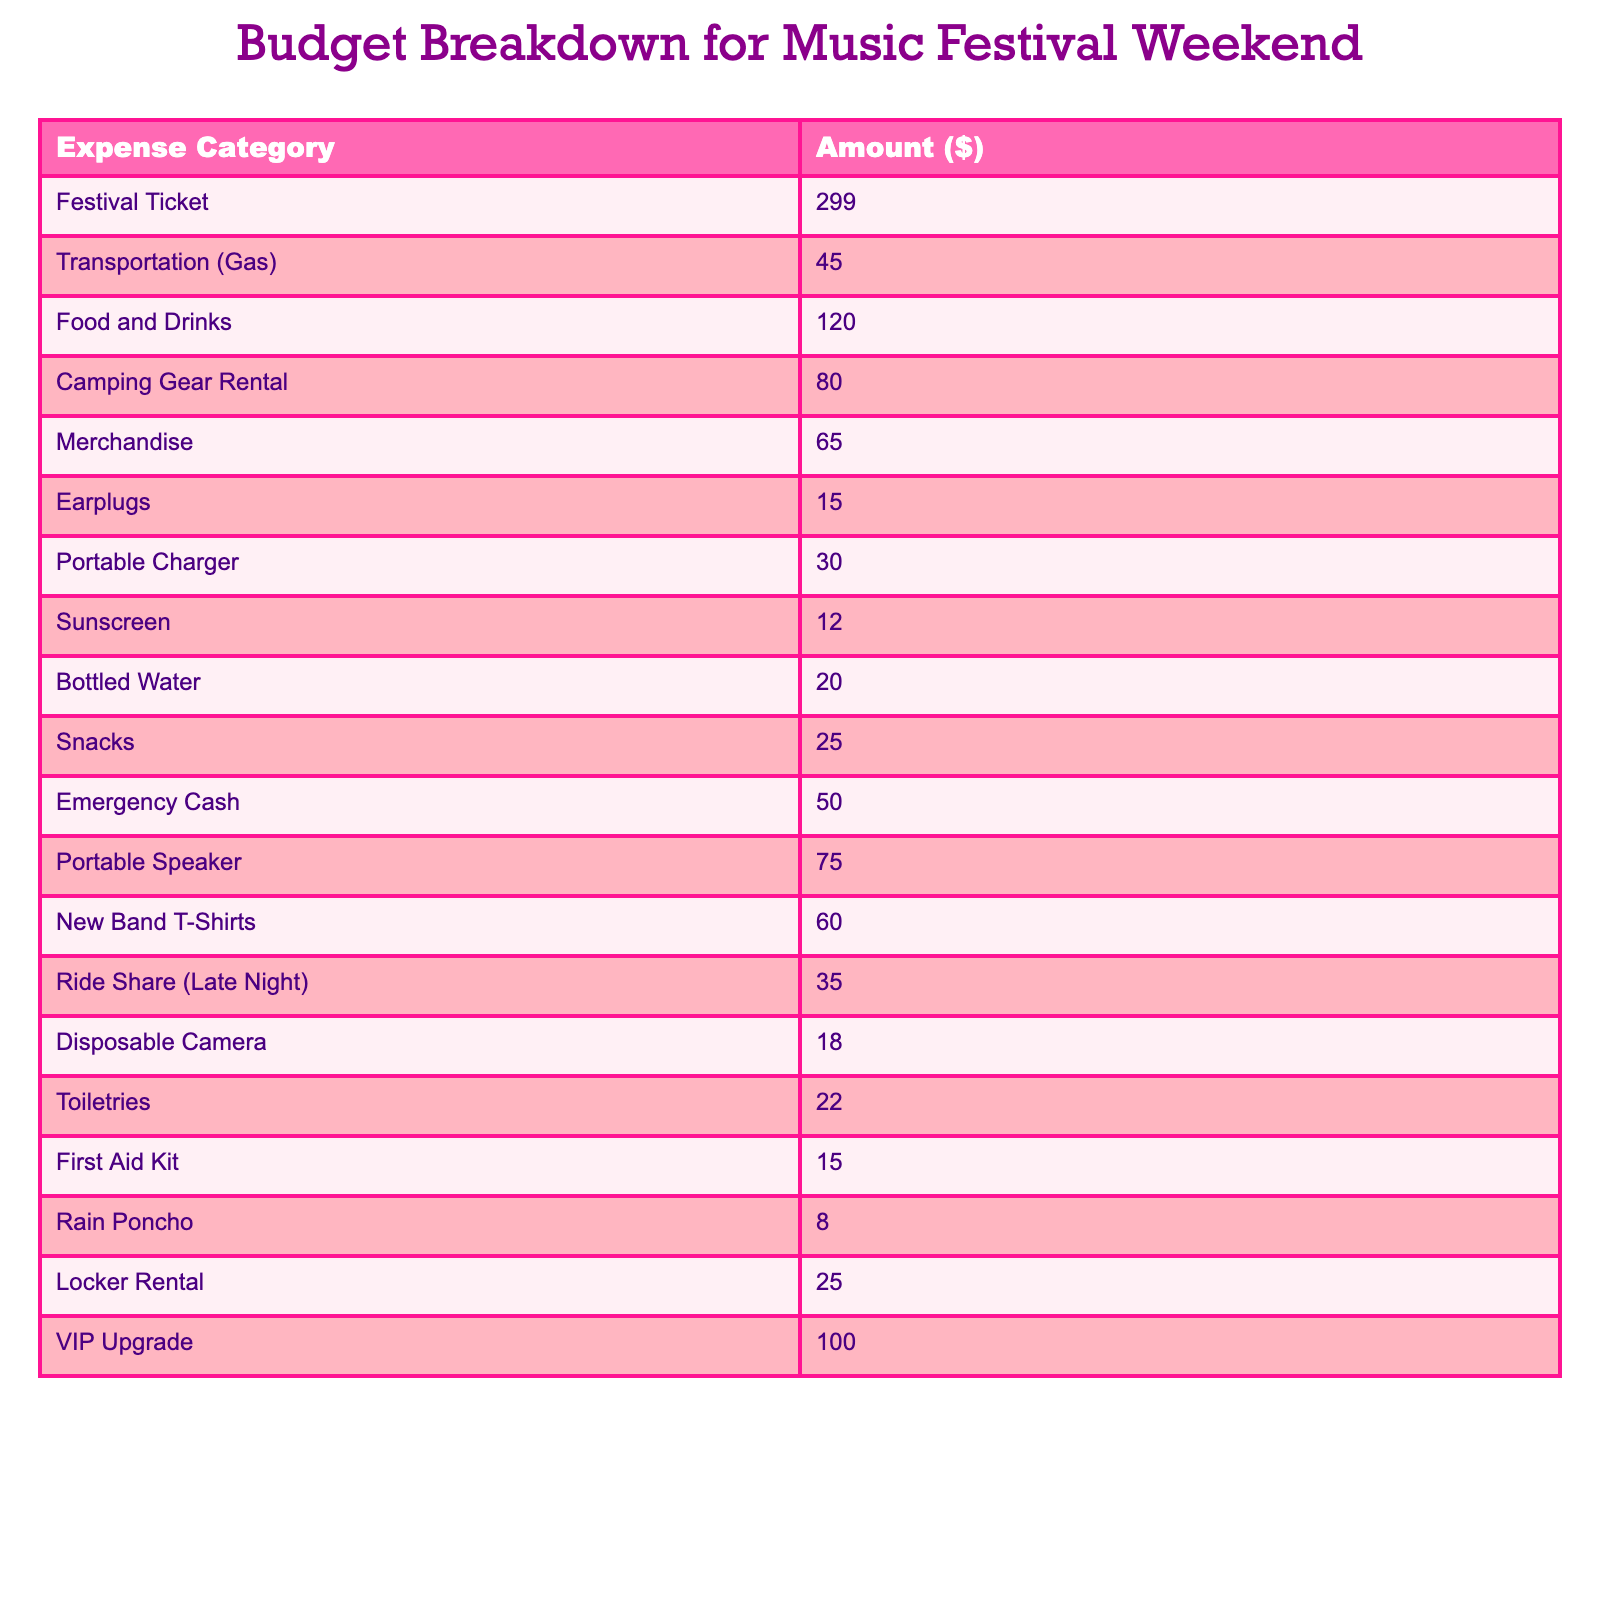What is the total amount spent on food and drinks? The table shows that the amount spent on food and drinks is $120.
Answer: 120 How much does the VIP upgrade cost? According to the table, the cost of the VIP upgrade is $100.
Answer: 100 What category has the highest expense? The festival ticket category has the highest expense at $299.
Answer: Festival Ticket How much was spent on transportation and snacks combined? Transportation costs $45, and snacks cost $25. Adding these gives $45 + $25 = $70.
Answer: 70 Is the total amount spent on merchandise greater than the amount spent on earplugs? Merchandise costs $65 and earplugs cost $15. Since $65 is greater than $15, the statement is true.
Answer: Yes What is the combined total for camping gear rental, bottled water, and toiletries? The camping gear rental is $80, bottled water is $20, and toiletries are $22. Adding these up gives $80 + $20 + $22 = $122.
Answer: 122 If a student decides to skip the new band t-shirts, how much would they save? The cost of the new band t-shirts is $60. By skipping this expense, they would save $60.
Answer: 60 What is the difference between the costs of the festival ticket and the portable speaker? The festival ticket costs $299 and the portable speaker costs $75. The difference is $299 - $75 = $224.
Answer: 224 What is the total amount spent on items related to personal care (earplugs, sunscreen, toiletries, first aid kit, and rain poncho)? Earplugs cost $15, sunscreen costs $12, toiletries are $22, first aid kit is $15, and rain poncho is $8. Adding these gives $15 + $12 + $22 + $15 + $8 = $72.
Answer: 72 What percentage of the total budget is spent on food and drinks? The total budget is the sum of all expenses, which is $799. Food and drinks cost $120. The percentage is calculated as ($120 / $799) * 100 ≈ 15%.
Answer: 15% 